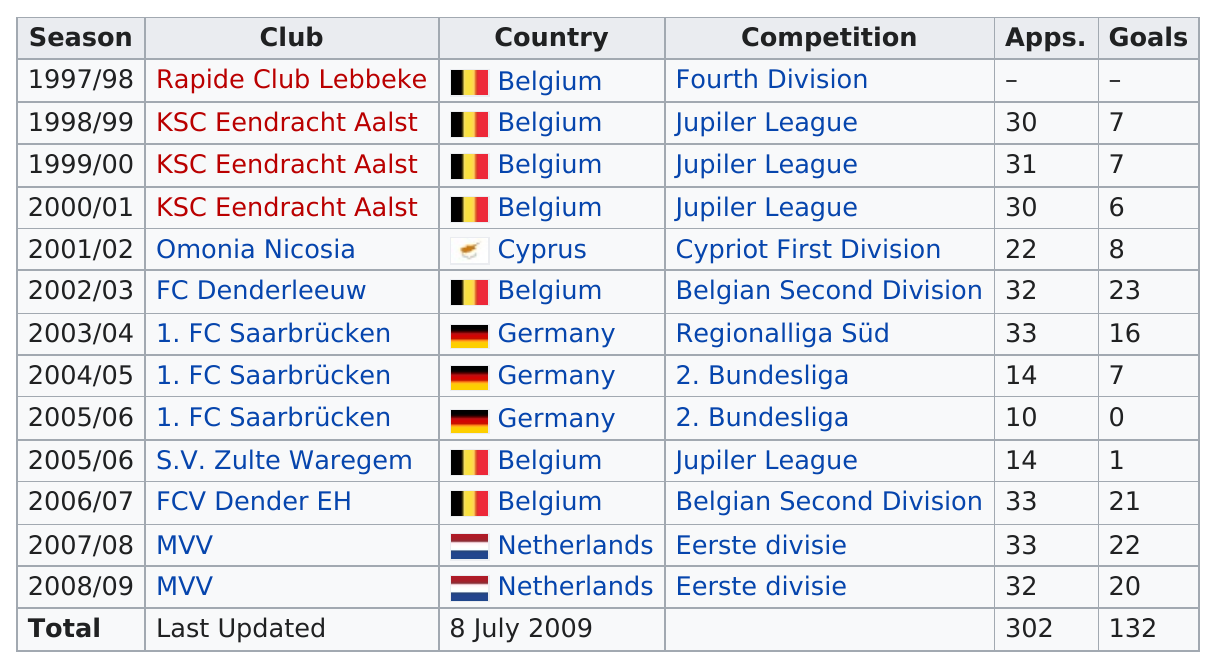Point out several critical features in this image. There were at least 20 goals scored in four seasons. Gunter Thiebaut scored the most goals in the 2002/2003 season. Gunter Thiebaut last played for MVV during the 2008/2009 season. Cyprus has the least amount of total goals among all countries, making it a standout in terms of scoring the least amount of goals. 1. FC Saarbrücken had the same number of goals as KSC Eendracht Aalst. 